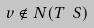Convert formula to latex. <formula><loc_0><loc_0><loc_500><loc_500>v \notin N ( T \ S )</formula> 